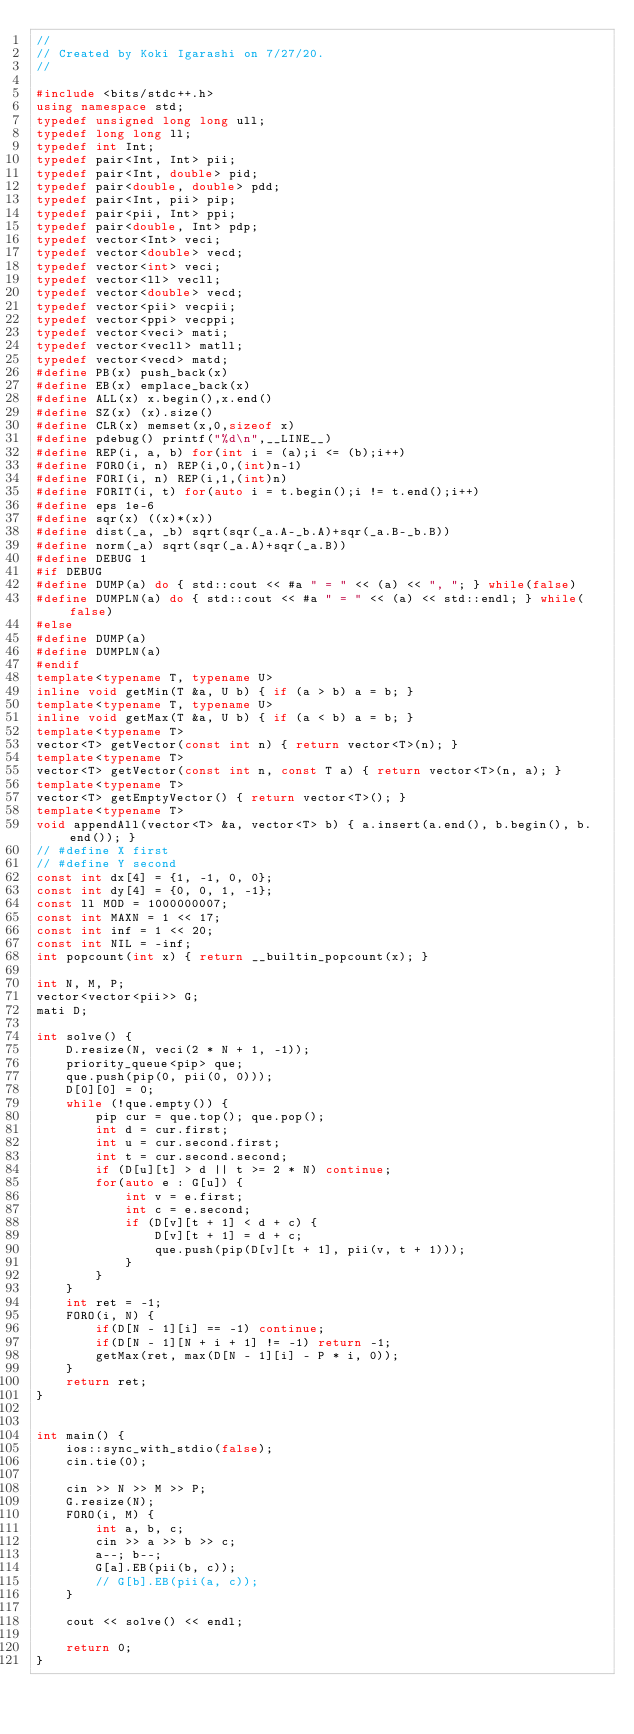Convert code to text. <code><loc_0><loc_0><loc_500><loc_500><_C++_>//
// Created by Koki Igarashi on 7/27/20.
//

#include <bits/stdc++.h>
using namespace std;
typedef unsigned long long ull;
typedef long long ll;
typedef int Int;
typedef pair<Int, Int> pii;
typedef pair<Int, double> pid;
typedef pair<double, double> pdd;
typedef pair<Int, pii> pip;
typedef pair<pii, Int> ppi;
typedef pair<double, Int> pdp;
typedef vector<Int> veci;
typedef vector<double> vecd;
typedef vector<int> veci;
typedef vector<ll> vecll;
typedef vector<double> vecd;
typedef vector<pii> vecpii;
typedef vector<ppi> vecppi;
typedef vector<veci> mati;
typedef vector<vecll> matll;
typedef vector<vecd> matd;
#define PB(x) push_back(x)
#define EB(x) emplace_back(x)
#define ALL(x) x.begin(),x.end()
#define SZ(x) (x).size()
#define CLR(x) memset(x,0,sizeof x)
#define pdebug() printf("%d\n",__LINE__)
#define REP(i, a, b) for(int i = (a);i <= (b);i++)
#define FORO(i, n) REP(i,0,(int)n-1)
#define FORI(i, n) REP(i,1,(int)n)
#define FORIT(i, t) for(auto i = t.begin();i != t.end();i++)
#define eps 1e-6
#define sqr(x) ((x)*(x))
#define dist(_a, _b) sqrt(sqr(_a.A-_b.A)+sqr(_a.B-_b.B))
#define norm(_a) sqrt(sqr(_a.A)+sqr(_a.B))
#define DEBUG 1
#if DEBUG
#define DUMP(a) do { std::cout << #a " = " << (a) << ", "; } while(false)
#define DUMPLN(a) do { std::cout << #a " = " << (a) << std::endl; } while(false)
#else
#define DUMP(a)
#define DUMPLN(a)
#endif
template<typename T, typename U>
inline void getMin(T &a, U b) { if (a > b) a = b; }
template<typename T, typename U>
inline void getMax(T &a, U b) { if (a < b) a = b; }
template<typename T>
vector<T> getVector(const int n) { return vector<T>(n); }
template<typename T>
vector<T> getVector(const int n, const T a) { return vector<T>(n, a); }
template<typename T>
vector<T> getEmptyVector() { return vector<T>(); }
template<typename T>
void appendAll(vector<T> &a, vector<T> b) { a.insert(a.end(), b.begin(), b.end()); }
// #define X first
// #define Y second
const int dx[4] = {1, -1, 0, 0};
const int dy[4] = {0, 0, 1, -1};
const ll MOD = 1000000007;
const int MAXN = 1 << 17;
const int inf = 1 << 20;
const int NIL = -inf;
int popcount(int x) { return __builtin_popcount(x); }

int N, M, P;
vector<vector<pii>> G;
mati D;

int solve() {
    D.resize(N, veci(2 * N + 1, -1));
    priority_queue<pip> que;
    que.push(pip(0, pii(0, 0)));
    D[0][0] = 0;
    while (!que.empty()) {
        pip cur = que.top(); que.pop();
        int d = cur.first;
        int u = cur.second.first;
        int t = cur.second.second;
        if (D[u][t] > d || t >= 2 * N) continue;
        for(auto e : G[u]) {
            int v = e.first;
            int c = e.second;
            if (D[v][t + 1] < d + c) {
                D[v][t + 1] = d + c;
                que.push(pip(D[v][t + 1], pii(v, t + 1)));
            }
        }
    }
    int ret = -1;
    FORO(i, N) {
        if(D[N - 1][i] == -1) continue;
        if(D[N - 1][N + i + 1] != -1) return -1;
        getMax(ret, max(D[N - 1][i] - P * i, 0));
    }
    return ret;
}


int main() {
    ios::sync_with_stdio(false);
    cin.tie(0);

    cin >> N >> M >> P;
    G.resize(N);
    FORO(i, M) {
        int a, b, c;
        cin >> a >> b >> c;
        a--; b--;
        G[a].EB(pii(b, c));
        // G[b].EB(pii(a, c));
    }

    cout << solve() << endl;

    return 0;
}</code> 